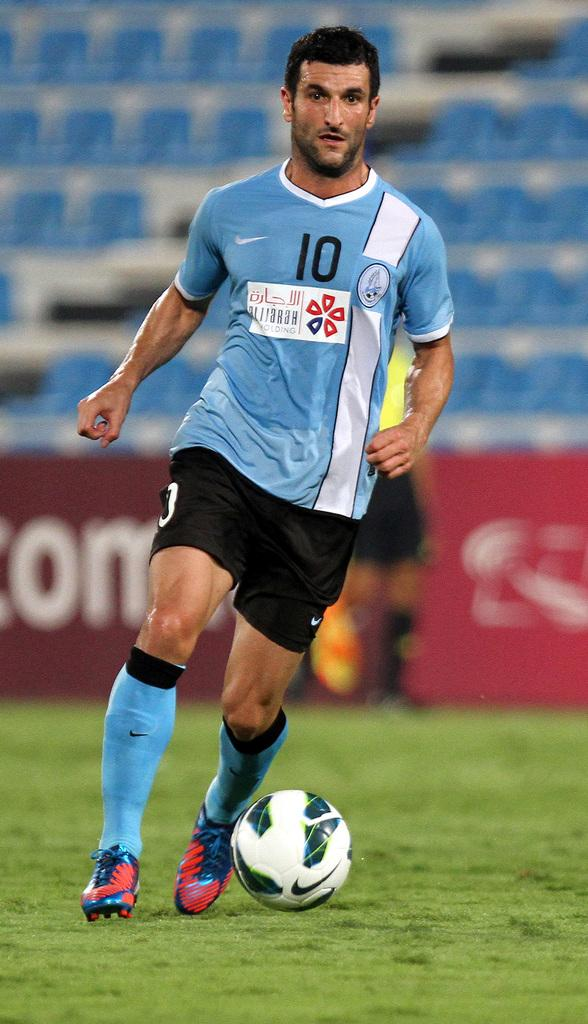<image>
Write a terse but informative summary of the picture. a man in number 10 jersey kicks a soccer ball 